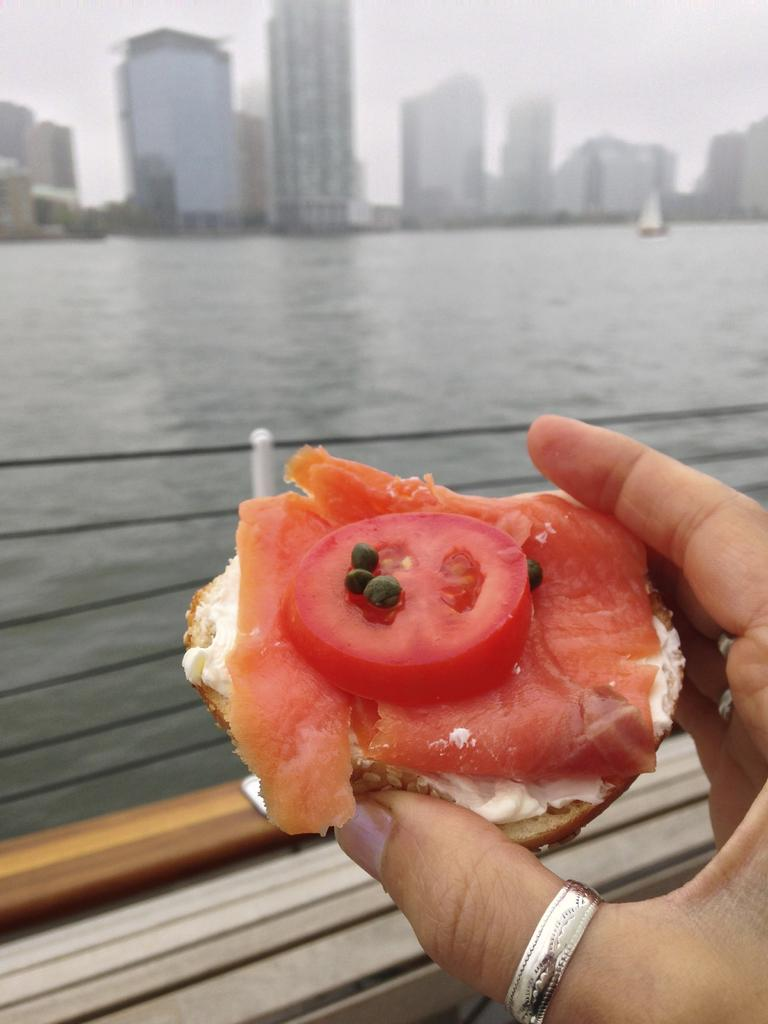What body part is visible in the image? There are fingers visible in the image. What else can be seen in the image besides the fingers? There is food in the image. What can be seen in the background of the image? There are buildings, water, a railing, and the sky visible in the background of the image. What type of jewel is being worn by the person in the image? There is no person or jewel visible in the image; only fingers, food, and background elements are present. 